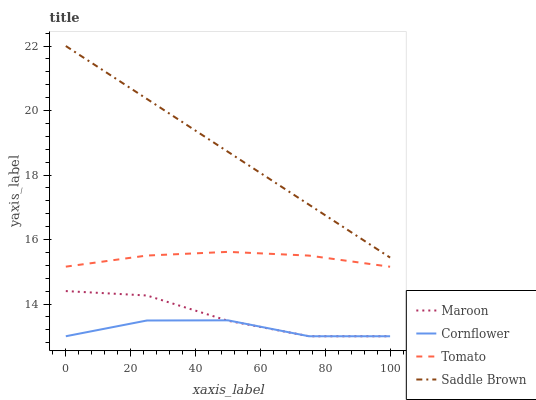Does Cornflower have the minimum area under the curve?
Answer yes or no. Yes. Does Saddle Brown have the maximum area under the curve?
Answer yes or no. Yes. Does Saddle Brown have the minimum area under the curve?
Answer yes or no. No. Does Cornflower have the maximum area under the curve?
Answer yes or no. No. Is Saddle Brown the smoothest?
Answer yes or no. Yes. Is Cornflower the roughest?
Answer yes or no. Yes. Is Cornflower the smoothest?
Answer yes or no. No. Is Saddle Brown the roughest?
Answer yes or no. No. Does Cornflower have the lowest value?
Answer yes or no. Yes. Does Saddle Brown have the lowest value?
Answer yes or no. No. Does Saddle Brown have the highest value?
Answer yes or no. Yes. Does Cornflower have the highest value?
Answer yes or no. No. Is Tomato less than Saddle Brown?
Answer yes or no. Yes. Is Tomato greater than Maroon?
Answer yes or no. Yes. Does Cornflower intersect Maroon?
Answer yes or no. Yes. Is Cornflower less than Maroon?
Answer yes or no. No. Is Cornflower greater than Maroon?
Answer yes or no. No. Does Tomato intersect Saddle Brown?
Answer yes or no. No. 